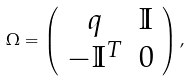Convert formula to latex. <formula><loc_0><loc_0><loc_500><loc_500>\Omega = \left ( \begin{array} { c c } { q } & \mathbb { I } \\ - \mathbb { I } ^ { T } & 0 \end{array} \right ) ,</formula> 